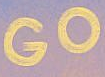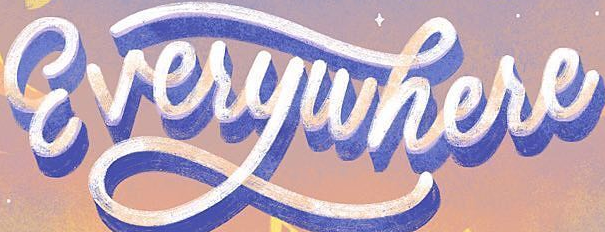What words are shown in these images in order, separated by a semicolon? GO; Everywhere 